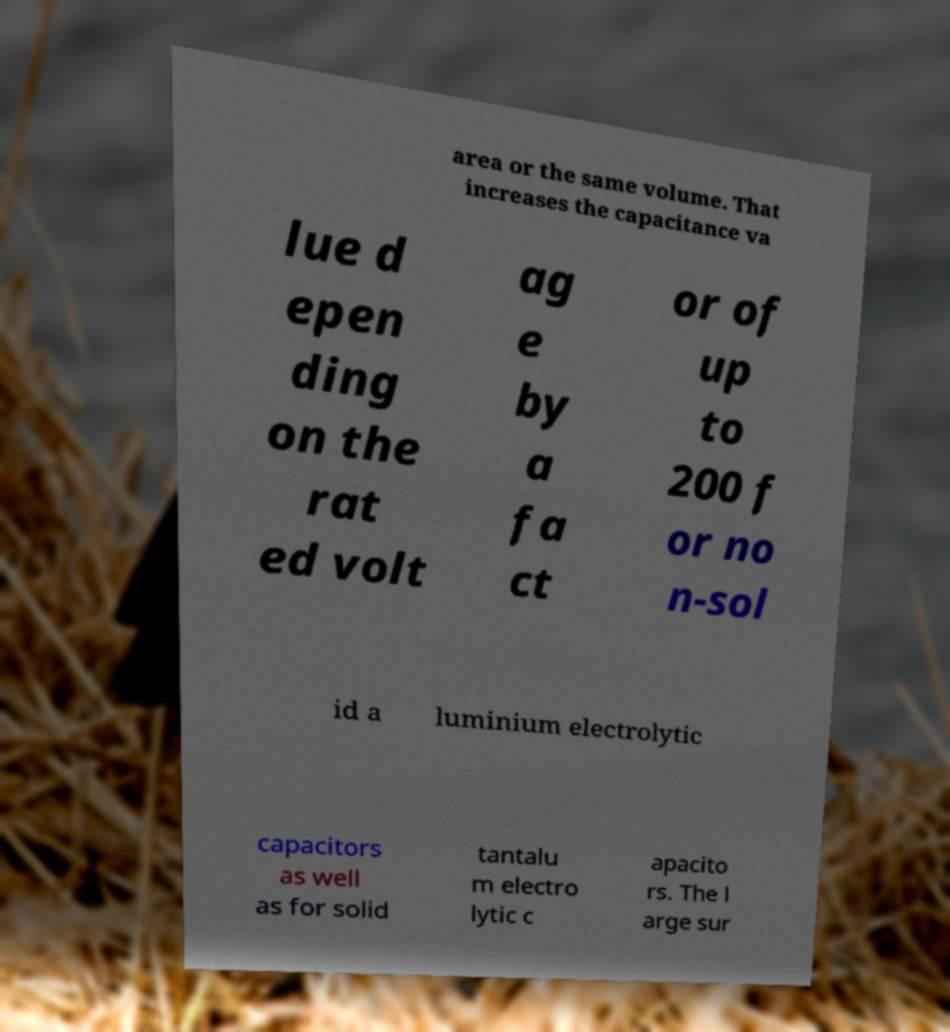Could you assist in decoding the text presented in this image and type it out clearly? area or the same volume. That increases the capacitance va lue d epen ding on the rat ed volt ag e by a fa ct or of up to 200 f or no n-sol id a luminium electrolytic capacitors as well as for solid tantalu m electro lytic c apacito rs. The l arge sur 